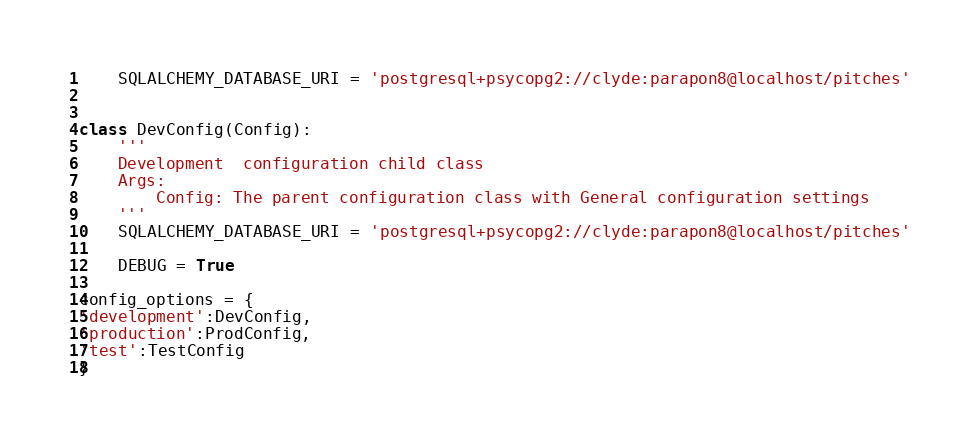Convert code to text. <code><loc_0><loc_0><loc_500><loc_500><_Python_>    SQLALCHEMY_DATABASE_URI = 'postgresql+psycopg2://clyde:parapon8@localhost/pitches'


class DevConfig(Config):
    '''
    Development  configuration child class
    Args:
        Config: The parent configuration class with General configuration settings
    '''
    SQLALCHEMY_DATABASE_URI = 'postgresql+psycopg2://clyde:parapon8@localhost/pitches'

    DEBUG = True

config_options = {
'development':DevConfig,
'production':ProdConfig,
'test':TestConfig
}</code> 